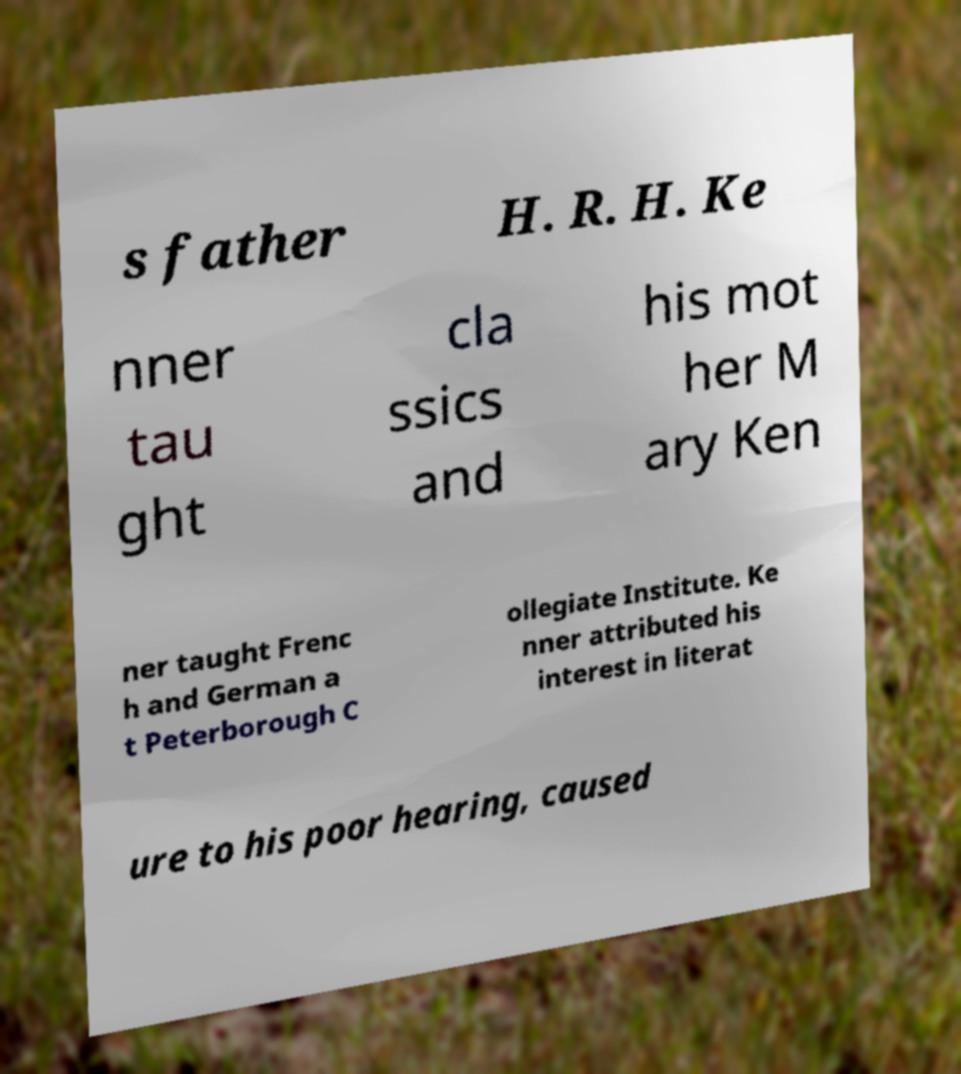For documentation purposes, I need the text within this image transcribed. Could you provide that? s father H. R. H. Ke nner tau ght cla ssics and his mot her M ary Ken ner taught Frenc h and German a t Peterborough C ollegiate Institute. Ke nner attributed his interest in literat ure to his poor hearing, caused 